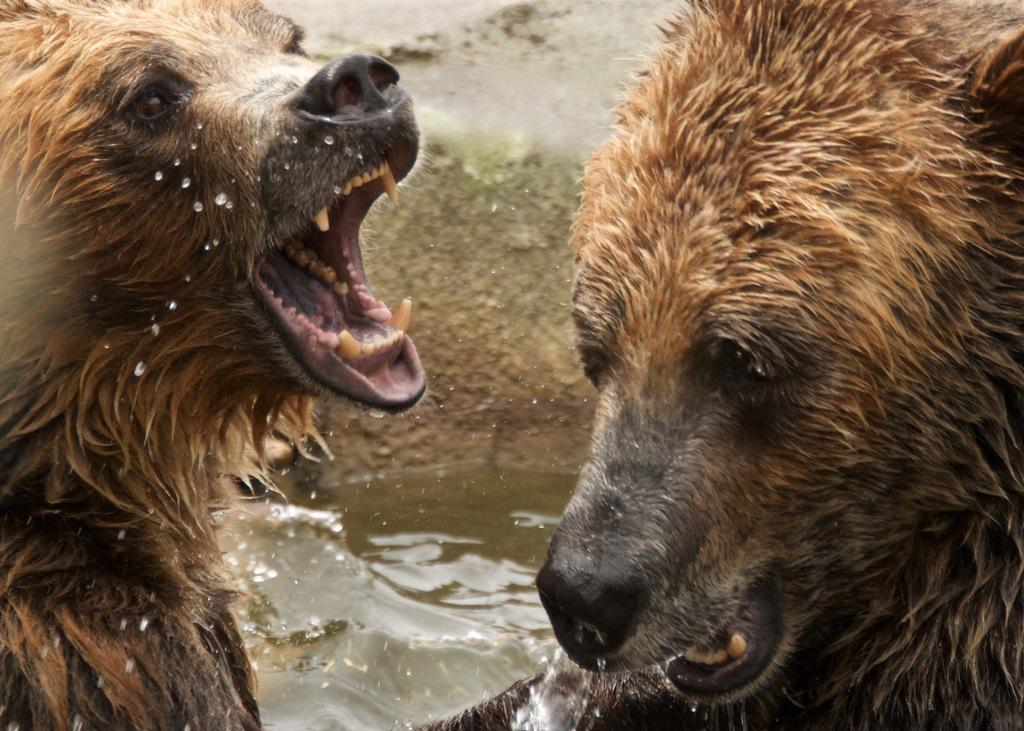What types of living organisms can be seen in the image? There are animals in the image. What is the primary element visible in the image? There is water visible in the image. What type of medical advice can be heard from the doctor in the image? There is no doctor present in the image, so no medical advice can be heard. 